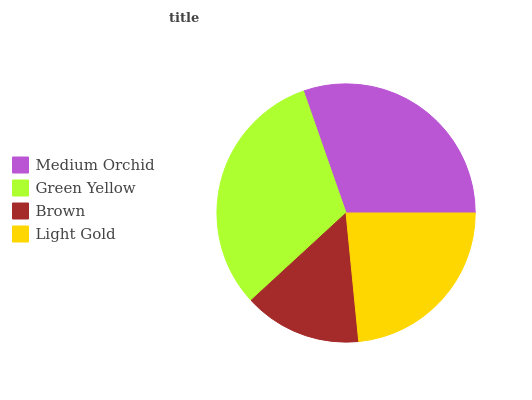Is Brown the minimum?
Answer yes or no. Yes. Is Green Yellow the maximum?
Answer yes or no. Yes. Is Green Yellow the minimum?
Answer yes or no. No. Is Brown the maximum?
Answer yes or no. No. Is Green Yellow greater than Brown?
Answer yes or no. Yes. Is Brown less than Green Yellow?
Answer yes or no. Yes. Is Brown greater than Green Yellow?
Answer yes or no. No. Is Green Yellow less than Brown?
Answer yes or no. No. Is Medium Orchid the high median?
Answer yes or no. Yes. Is Light Gold the low median?
Answer yes or no. Yes. Is Green Yellow the high median?
Answer yes or no. No. Is Green Yellow the low median?
Answer yes or no. No. 